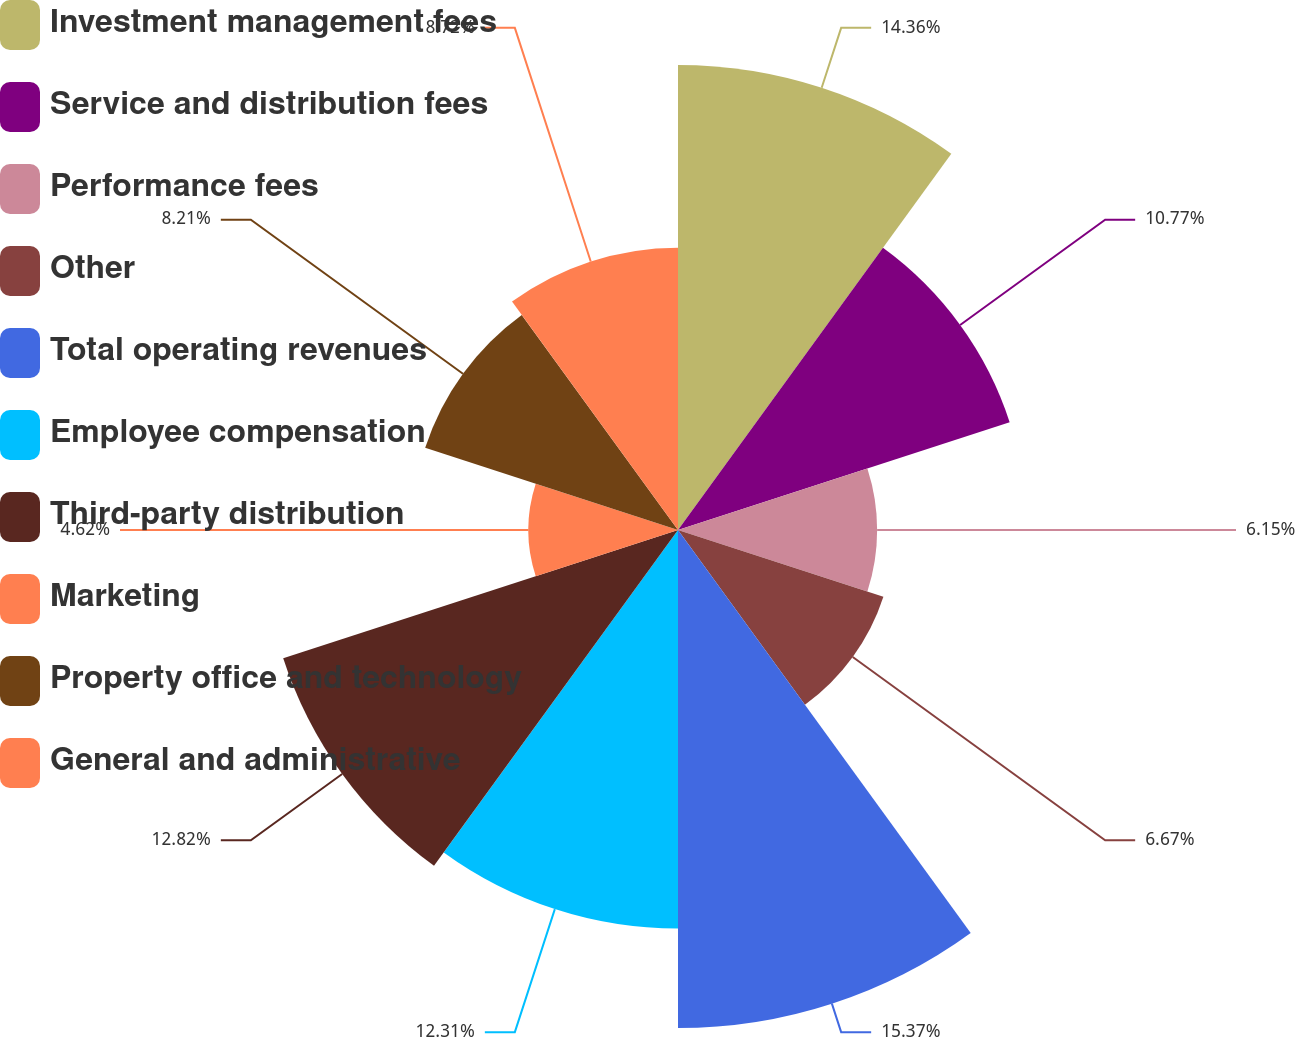<chart> <loc_0><loc_0><loc_500><loc_500><pie_chart><fcel>Investment management fees<fcel>Service and distribution fees<fcel>Performance fees<fcel>Other<fcel>Total operating revenues<fcel>Employee compensation<fcel>Third-party distribution<fcel>Marketing<fcel>Property office and technology<fcel>General and administrative<nl><fcel>14.36%<fcel>10.77%<fcel>6.15%<fcel>6.67%<fcel>15.38%<fcel>12.31%<fcel>12.82%<fcel>4.62%<fcel>8.21%<fcel>8.72%<nl></chart> 